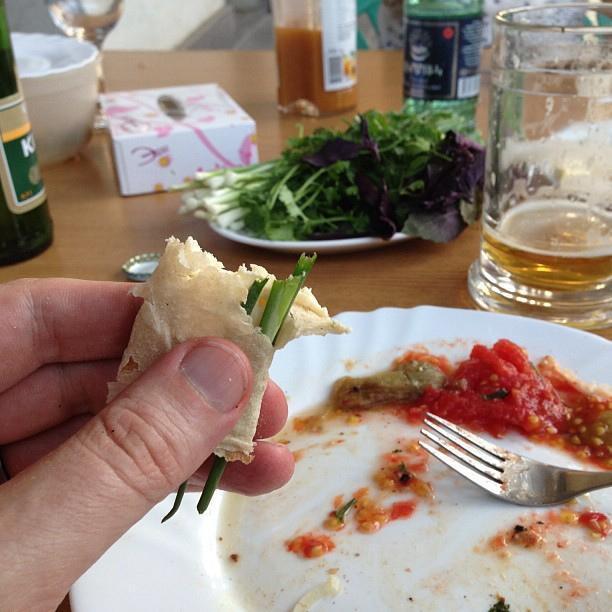How many prongs are on the fork?
Give a very brief answer. 4. How many people are visible?
Give a very brief answer. 2. How many bottles are visible?
Give a very brief answer. 3. 